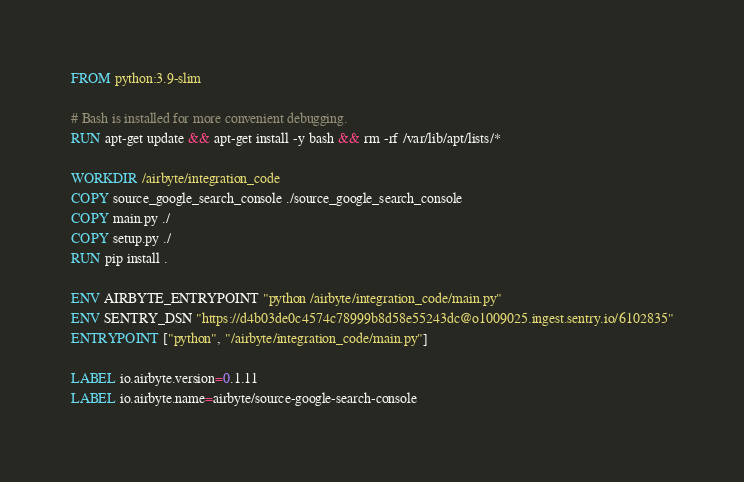Convert code to text. <code><loc_0><loc_0><loc_500><loc_500><_Dockerfile_>FROM python:3.9-slim

# Bash is installed for more convenient debugging.
RUN apt-get update && apt-get install -y bash && rm -rf /var/lib/apt/lists/*

WORKDIR /airbyte/integration_code
COPY source_google_search_console ./source_google_search_console
COPY main.py ./
COPY setup.py ./
RUN pip install .

ENV AIRBYTE_ENTRYPOINT "python /airbyte/integration_code/main.py"
ENV SENTRY_DSN "https://d4b03de0c4574c78999b8d58e55243dc@o1009025.ingest.sentry.io/6102835"
ENTRYPOINT ["python", "/airbyte/integration_code/main.py"]

LABEL io.airbyte.version=0.1.11
LABEL io.airbyte.name=airbyte/source-google-search-console
</code> 